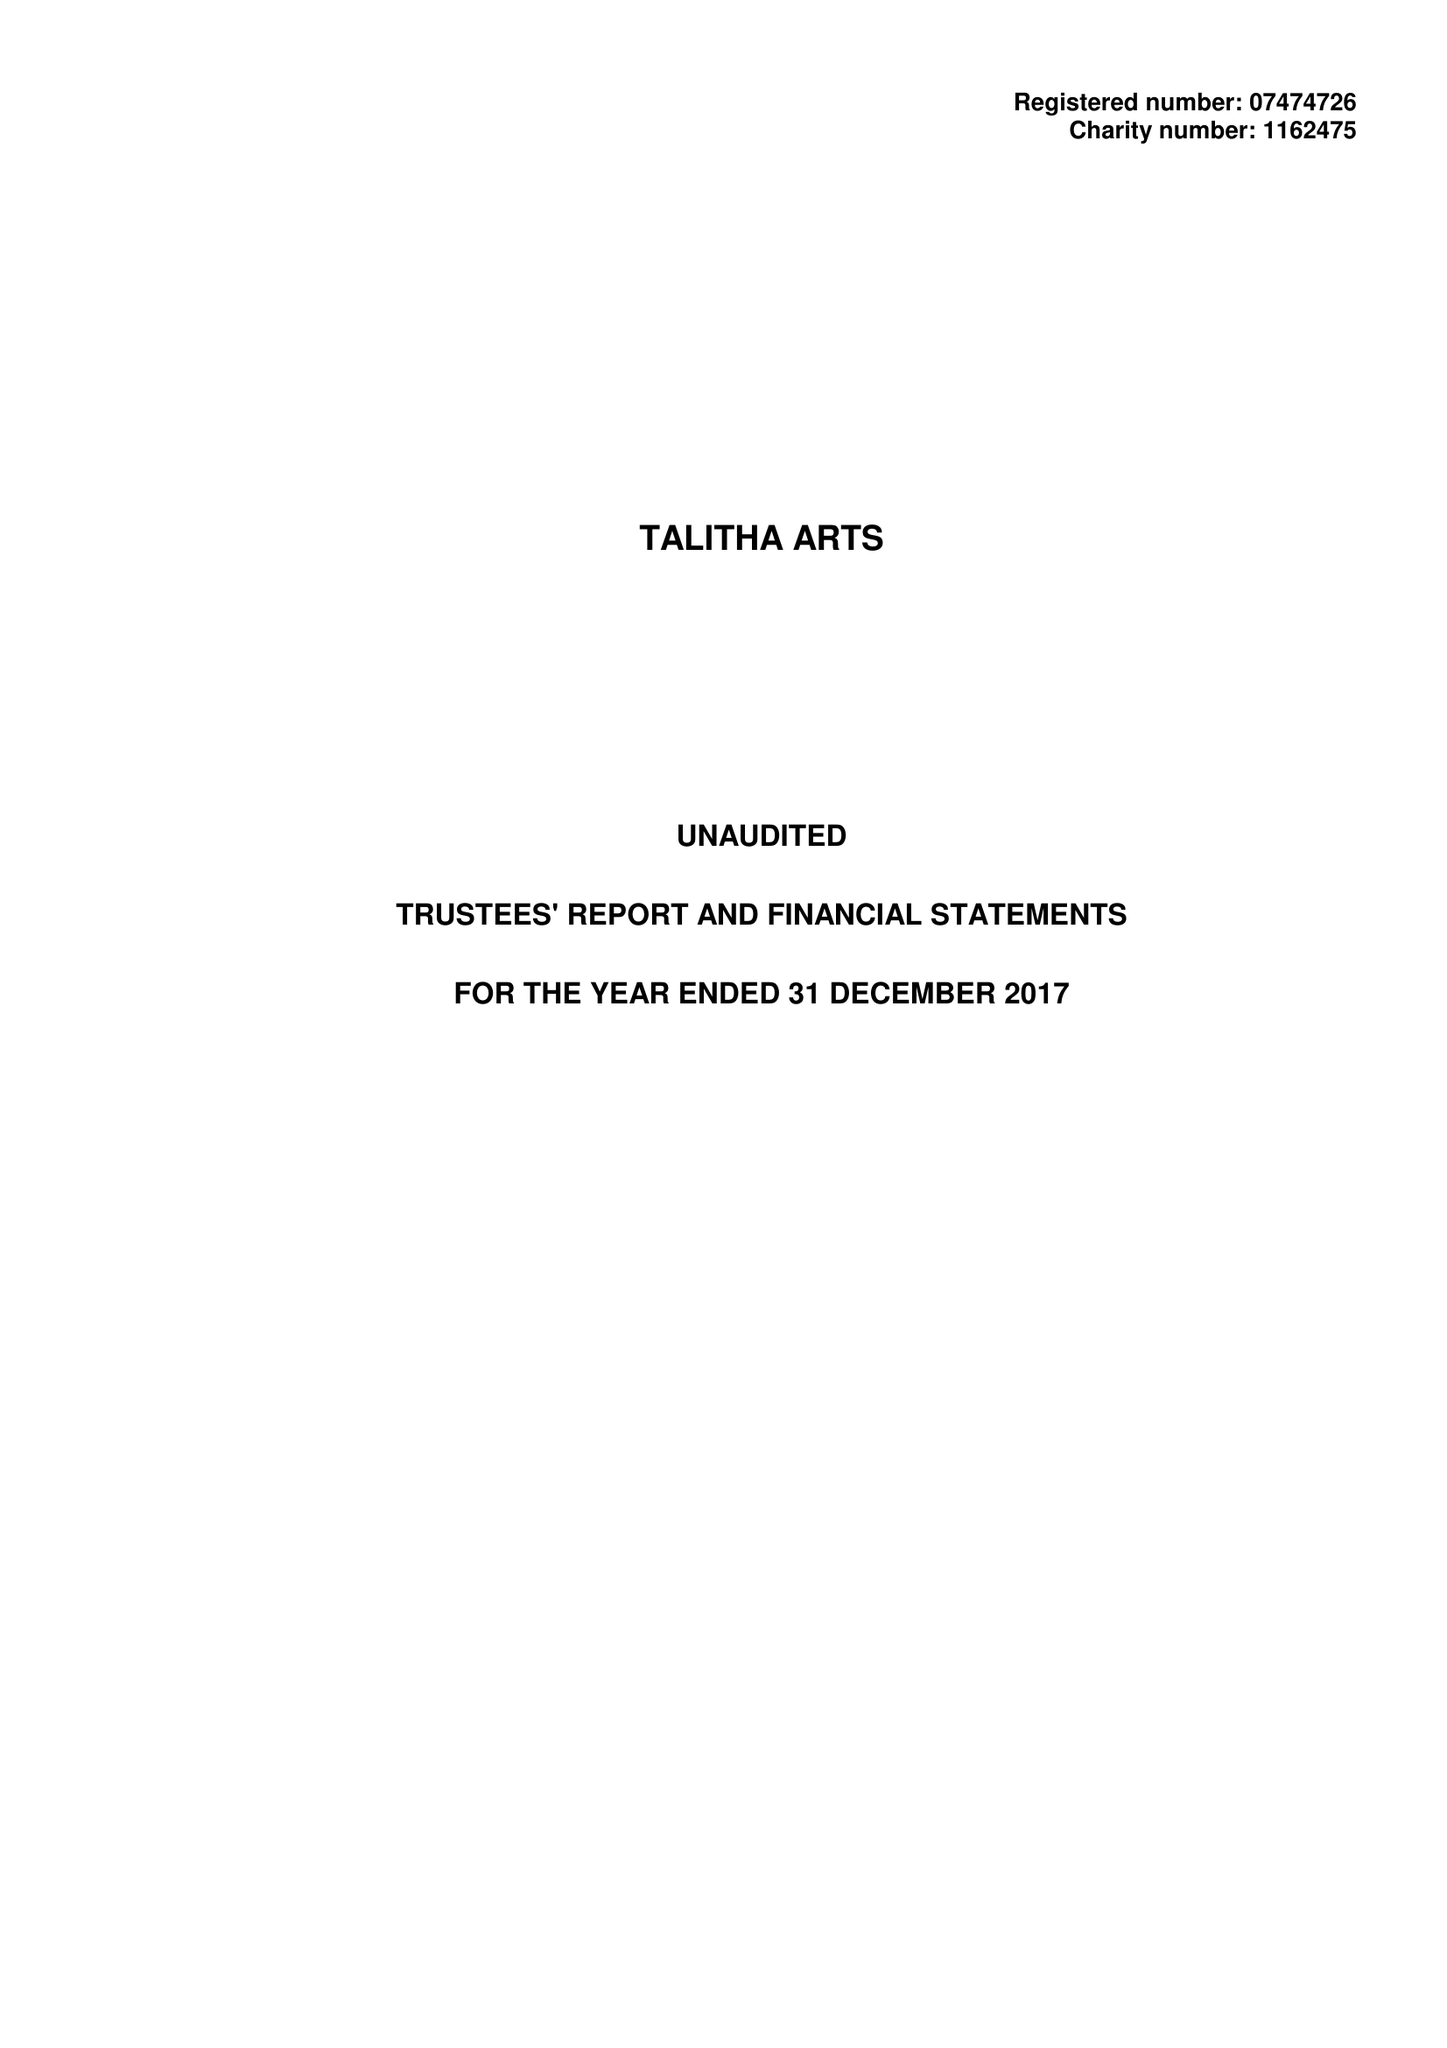What is the value for the address__street_line?
Answer the question using a single word or phrase. 5 CLARENCE ROAD 